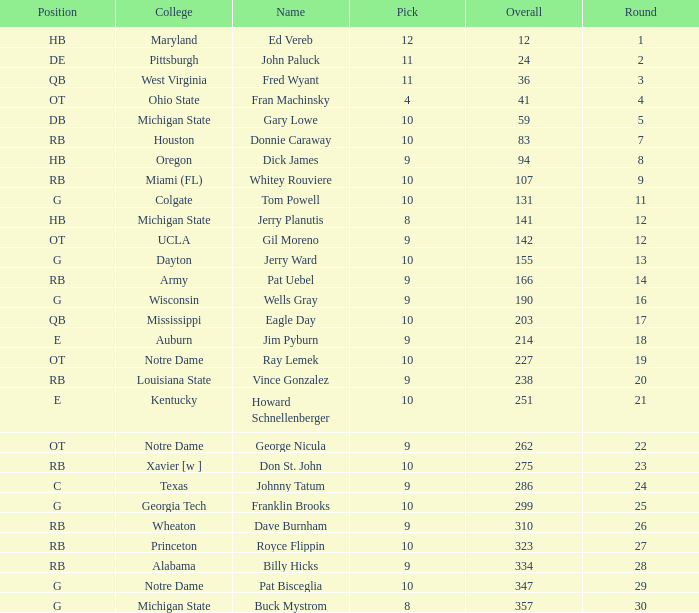What is the overall pick number for a draft pick smaller than 9, named buck mystrom from Michigan State college? 357.0. 